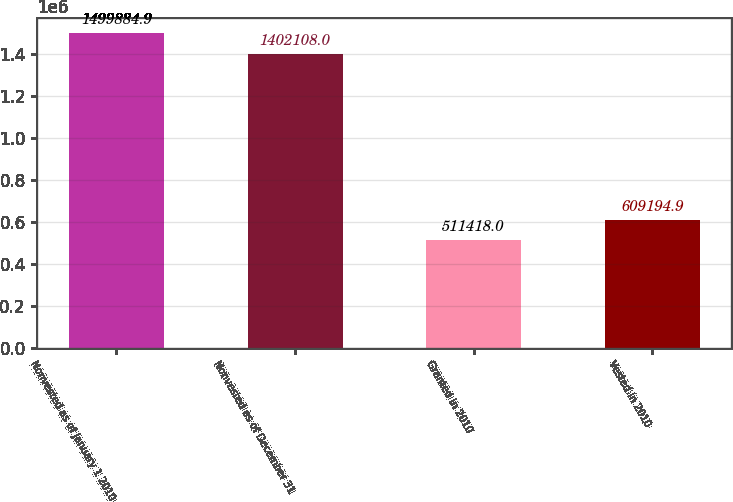<chart> <loc_0><loc_0><loc_500><loc_500><bar_chart><fcel>Nonvested as of January 1 2010<fcel>Nonvested as of December 31<fcel>Granted in 2010<fcel>Vested in 2010<nl><fcel>1.49988e+06<fcel>1.40211e+06<fcel>511418<fcel>609195<nl></chart> 